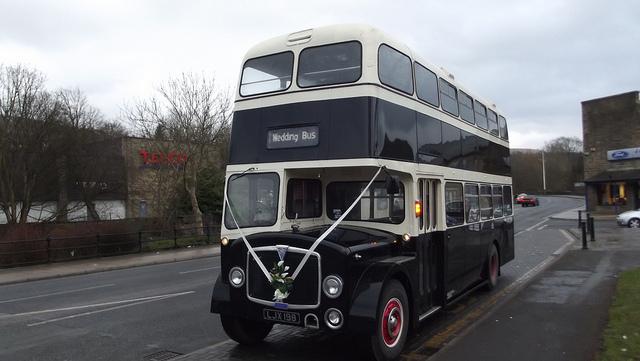How many lights are on the front of the bus?
Answer briefly. 3. What color are the wheels on the bus?
Concise answer only. Red. How many stories are on this bus?
Concise answer only. 2. 